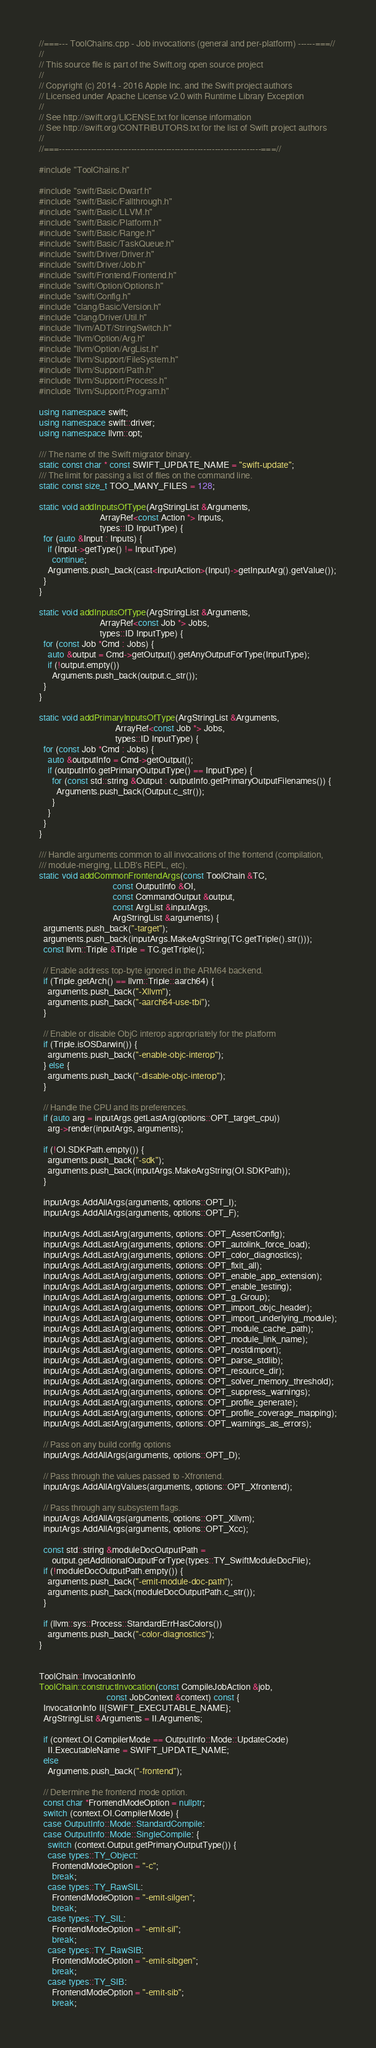<code> <loc_0><loc_0><loc_500><loc_500><_C++_>//===--- ToolChains.cpp - Job invocations (general and per-platform) ------===//
//
// This source file is part of the Swift.org open source project
//
// Copyright (c) 2014 - 2016 Apple Inc. and the Swift project authors
// Licensed under Apache License v2.0 with Runtime Library Exception
//
// See http://swift.org/LICENSE.txt for license information
// See http://swift.org/CONTRIBUTORS.txt for the list of Swift project authors
//
//===----------------------------------------------------------------------===//

#include "ToolChains.h"

#include "swift/Basic/Dwarf.h"
#include "swift/Basic/Fallthrough.h"
#include "swift/Basic/LLVM.h"
#include "swift/Basic/Platform.h"
#include "swift/Basic/Range.h"
#include "swift/Basic/TaskQueue.h"
#include "swift/Driver/Driver.h"
#include "swift/Driver/Job.h"
#include "swift/Frontend/Frontend.h"
#include "swift/Option/Options.h"
#include "swift/Config.h"
#include "clang/Basic/Version.h"
#include "clang/Driver/Util.h"
#include "llvm/ADT/StringSwitch.h"
#include "llvm/Option/Arg.h"
#include "llvm/Option/ArgList.h"
#include "llvm/Support/FileSystem.h"
#include "llvm/Support/Path.h"
#include "llvm/Support/Process.h"
#include "llvm/Support/Program.h"

using namespace swift;
using namespace swift::driver;
using namespace llvm::opt;

/// The name of the Swift migrator binary.
static const char * const SWIFT_UPDATE_NAME = "swift-update";
/// The limit for passing a list of files on the command line.
static const size_t TOO_MANY_FILES = 128;

static void addInputsOfType(ArgStringList &Arguments,
                            ArrayRef<const Action *> Inputs,
                            types::ID InputType) {
  for (auto &Input : Inputs) {
    if (Input->getType() != InputType)
      continue;
    Arguments.push_back(cast<InputAction>(Input)->getInputArg().getValue());
  }
}

static void addInputsOfType(ArgStringList &Arguments,
                            ArrayRef<const Job *> Jobs,
                            types::ID InputType) {
  for (const Job *Cmd : Jobs) {
    auto &output = Cmd->getOutput().getAnyOutputForType(InputType);
    if (!output.empty())
      Arguments.push_back(output.c_str());
  }
}

static void addPrimaryInputsOfType(ArgStringList &Arguments,
                                   ArrayRef<const Job *> Jobs,
                                   types::ID InputType) {
  for (const Job *Cmd : Jobs) {
    auto &outputInfo = Cmd->getOutput();
    if (outputInfo.getPrimaryOutputType() == InputType) {
      for (const std::string &Output : outputInfo.getPrimaryOutputFilenames()) {
        Arguments.push_back(Output.c_str());
      }
    }
  }
}

/// Handle arguments common to all invocations of the frontend (compilation,
/// module-merging, LLDB's REPL, etc).
static void addCommonFrontendArgs(const ToolChain &TC,
                                  const OutputInfo &OI,
                                  const CommandOutput &output,
                                  const ArgList &inputArgs,
                                  ArgStringList &arguments) {
  arguments.push_back("-target");
  arguments.push_back(inputArgs.MakeArgString(TC.getTriple().str()));
  const llvm::Triple &Triple = TC.getTriple();

  // Enable address top-byte ignored in the ARM64 backend.
  if (Triple.getArch() == llvm::Triple::aarch64) {
    arguments.push_back("-Xllvm");
    arguments.push_back("-aarch64-use-tbi");
  }

  // Enable or disable ObjC interop appropriately for the platform
  if (Triple.isOSDarwin()) {
    arguments.push_back("-enable-objc-interop");
  } else {
    arguments.push_back("-disable-objc-interop");
  }

  // Handle the CPU and its preferences.
  if (auto arg = inputArgs.getLastArg(options::OPT_target_cpu))
    arg->render(inputArgs, arguments);

  if (!OI.SDKPath.empty()) {
    arguments.push_back("-sdk");
    arguments.push_back(inputArgs.MakeArgString(OI.SDKPath));
  }

  inputArgs.AddAllArgs(arguments, options::OPT_I);
  inputArgs.AddAllArgs(arguments, options::OPT_F);

  inputArgs.AddLastArg(arguments, options::OPT_AssertConfig);
  inputArgs.AddLastArg(arguments, options::OPT_autolink_force_load);
  inputArgs.AddLastArg(arguments, options::OPT_color_diagnostics);
  inputArgs.AddLastArg(arguments, options::OPT_fixit_all);
  inputArgs.AddLastArg(arguments, options::OPT_enable_app_extension);
  inputArgs.AddLastArg(arguments, options::OPT_enable_testing);
  inputArgs.AddLastArg(arguments, options::OPT_g_Group);
  inputArgs.AddLastArg(arguments, options::OPT_import_objc_header);
  inputArgs.AddLastArg(arguments, options::OPT_import_underlying_module);
  inputArgs.AddLastArg(arguments, options::OPT_module_cache_path);
  inputArgs.AddLastArg(arguments, options::OPT_module_link_name);
  inputArgs.AddLastArg(arguments, options::OPT_nostdimport);
  inputArgs.AddLastArg(arguments, options::OPT_parse_stdlib);
  inputArgs.AddLastArg(arguments, options::OPT_resource_dir);
  inputArgs.AddLastArg(arguments, options::OPT_solver_memory_threshold);
  inputArgs.AddLastArg(arguments, options::OPT_suppress_warnings);
  inputArgs.AddLastArg(arguments, options::OPT_profile_generate);
  inputArgs.AddLastArg(arguments, options::OPT_profile_coverage_mapping);
  inputArgs.AddLastArg(arguments, options::OPT_warnings_as_errors);

  // Pass on any build config options
  inputArgs.AddAllArgs(arguments, options::OPT_D);

  // Pass through the values passed to -Xfrontend.
  inputArgs.AddAllArgValues(arguments, options::OPT_Xfrontend);

  // Pass through any subsystem flags.
  inputArgs.AddAllArgs(arguments, options::OPT_Xllvm);
  inputArgs.AddAllArgs(arguments, options::OPT_Xcc);

  const std::string &moduleDocOutputPath =
      output.getAdditionalOutputForType(types::TY_SwiftModuleDocFile);
  if (!moduleDocOutputPath.empty()) {
    arguments.push_back("-emit-module-doc-path");
    arguments.push_back(moduleDocOutputPath.c_str());
  }

  if (llvm::sys::Process::StandardErrHasColors())
    arguments.push_back("-color-diagnostics");
}


ToolChain::InvocationInfo
ToolChain::constructInvocation(const CompileJobAction &job,
                               const JobContext &context) const {
  InvocationInfo II{SWIFT_EXECUTABLE_NAME};
  ArgStringList &Arguments = II.Arguments;

  if (context.OI.CompilerMode == OutputInfo::Mode::UpdateCode)
    II.ExecutableName = SWIFT_UPDATE_NAME;
  else
    Arguments.push_back("-frontend");

  // Determine the frontend mode option.
  const char *FrontendModeOption = nullptr;
  switch (context.OI.CompilerMode) {
  case OutputInfo::Mode::StandardCompile:
  case OutputInfo::Mode::SingleCompile: {
    switch (context.Output.getPrimaryOutputType()) {
    case types::TY_Object:
      FrontendModeOption = "-c";
      break;
    case types::TY_RawSIL:
      FrontendModeOption = "-emit-silgen";
      break;
    case types::TY_SIL:
      FrontendModeOption = "-emit-sil";
      break;
    case types::TY_RawSIB:
      FrontendModeOption = "-emit-sibgen";
      break;
    case types::TY_SIB:
      FrontendModeOption = "-emit-sib";
      break;</code> 